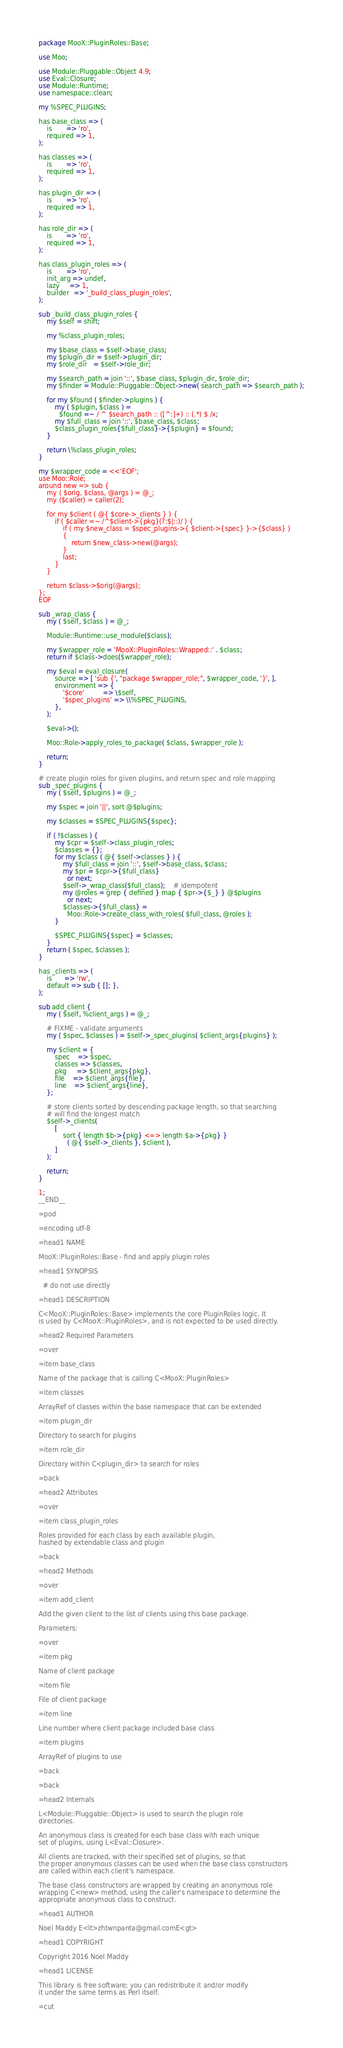Convert code to text. <code><loc_0><loc_0><loc_500><loc_500><_Perl_>package MooX::PluginRoles::Base;

use Moo;

use Module::Pluggable::Object 4.9;
use Eval::Closure;
use Module::Runtime;
use namespace::clean;

my %SPEC_PLUGINS;

has base_class => (
    is       => 'ro',
    required => 1,
);

has classes => (
    is       => 'ro',
    required => 1,
);

has plugin_dir => (
    is       => 'ro',
    required => 1,
);

has role_dir => (
    is       => 'ro',
    required => 1,
);

has class_plugin_roles => (
    is       => 'ro',
    init_arg => undef,
    lazy     => 1,
    builder  => '_build_class_plugin_roles',
);

sub _build_class_plugin_roles {
    my $self = shift;

    my %class_plugin_roles;

    my $base_class = $self->base_class;
    my $plugin_dir = $self->plugin_dir;
    my $role_dir   = $self->role_dir;

    my $search_path = join '::', $base_class, $plugin_dir, $role_dir;
    my $finder = Module::Pluggable::Object->new( search_path => $search_path );

    for my $found ( $finder->plugins ) {
        my ( $plugin, $class ) =
          $found =~ / ^ $search_path :: ([^:]+) :: (.*) $ /x;
        my $full_class = join '::', $base_class, $class;
        $class_plugin_roles{$full_class}->{$plugin} = $found;
    }

    return \%class_plugin_roles;
}

my $wrapper_code = <<'EOF';
use Moo::Role;
around new => sub {
    my ( $orig, $class, @args ) = @_;
    my ($caller) = caller(2);

    for my $client ( @{ $core->_clients } ) {
        if ( $caller =~ /^$client->{pkg}(?:$|::)/ ) {
            if ( my $new_class = $spec_plugins->{ $client->{spec} }->{$class} )
            {
                return $new_class->new(@args);
            }
            last;
        }
    }

    return $class->$orig(@args);
};
EOF

sub _wrap_class {
    my ( $self, $class ) = @_;

    Module::Runtime::use_module($class);

    my $wrapper_role = 'MooX::PluginRoles::Wrapped::' . $class;
    return if $class->does($wrapper_role);

    my $eval = eval_closure(
        source => [ 'sub {', "package $wrapper_role;", $wrapper_code, '}', ],
        environment => {
            '$core'         => \$self,
            '$spec_plugins' => \\%SPEC_PLUGINS,
        },
    );

    $eval->();

    Moo::Role->apply_roles_to_package( $class, $wrapper_role );

    return;
}

# create plugin roles for given plugins, and return spec and role mapping
sub _spec_plugins {
    my ( $self, $plugins ) = @_;

    my $spec = join '||', sort @$plugins;

    my $classes = $SPEC_PLUGINS{$spec};

    if ( !$classes ) {
        my $cpr = $self->class_plugin_roles;
        $classes = {};
        for my $class ( @{ $self->classes } ) {
            my $full_class = join '::', $self->base_class, $class;
            my $pr = $cpr->{$full_class}
              or next;
            $self->_wrap_class($full_class);    # idempotent
            my @roles = grep { defined } map { $pr->{$_} } @$plugins
              or next;
            $classes->{$full_class} =
              Moo::Role->create_class_with_roles( $full_class, @roles );
        }

        $SPEC_PLUGINS{$spec} = $classes;
    }
    return ( $spec, $classes );
}

has _clients => (
    is      => 'rw',
    default => sub { []; },
);

sub add_client {
    my ( $self, %client_args ) = @_;

    # FIXME - validate arguments
    my ( $spec, $classes ) = $self->_spec_plugins( $client_args{plugins} );

    my $client = {
        spec    => $spec,
        classes => $classes,
        pkg     => $client_args{pkg},
        file    => $client_args{file},
        line    => $client_args{line},
    };

    # store clients sorted by descending package length, so that searching
    # will find the longest match
    $self->_clients(
        [
            sort { length $b->{pkg} <=> length $a->{pkg} }
              ( @{ $self->_clients }, $client ),
        ]
    );

    return;
}

1;
__END__

=pod

=encoding utf-8

=head1 NAME

MooX::PluginRoles::Base - find and apply plugin roles

=head1 SYNOPSIS

  # do not use directly

=head1 DESCRIPTION

C<MooX::PluginRoles::Base> implements the core PluginRoles logic. It
is used by C<MooX::PluginRoles>, and is not expected to be used directly.

=head2 Required Parameters

=over

=item base_class

Name of the package that is calling C<MooX::PluginRoles>

=item classes

ArrayRef of classes within the base namespace that can be extended

=item plugin_dir

Directory to search for plugins

=item role_dir

Directory within C<plugin_dir> to search for roles

=back

=head2 Attributes

=over

=item class_plugin_roles

Roles provided for each class by each available plugin,
hashed by extendable class and plugin

=back

=head2 Methods

=over

=item add_client

Add the given client to the list of clients using this base package.

Parameters:

=over

=item pkg

Name of client package

=item file

File of client package

=item line

Line number where client package included base class

=item plugins

ArrayRef of plugins to use

=back

=back

=head2 Internals

L<Module::Pluggable::Object> is used to search the plugin role
directories.

An anonymous class is created for each base class with each unique
set of plugins, using L<Eval::Closure>.

All clients are tracked, with their specified set of plugins, so that
the proper anonymous classes can be used when the base class constructors
are called within each client's namespace.

The base class constructors are wrapped by creating an anonymous role
wrapping C<new> method, using the caller's namespace to determine the
appropriate anonymous class to construct.

=head1 AUTHOR

Noel Maddy E<lt>zhtwnpanta@gmail.comE<gt>

=head1 COPYRIGHT

Copyright 2016 Noel Maddy

=head1 LICENSE

This library is free software; you can redistribute it and/or modify
it under the same terms as Perl itself.

=cut
</code> 